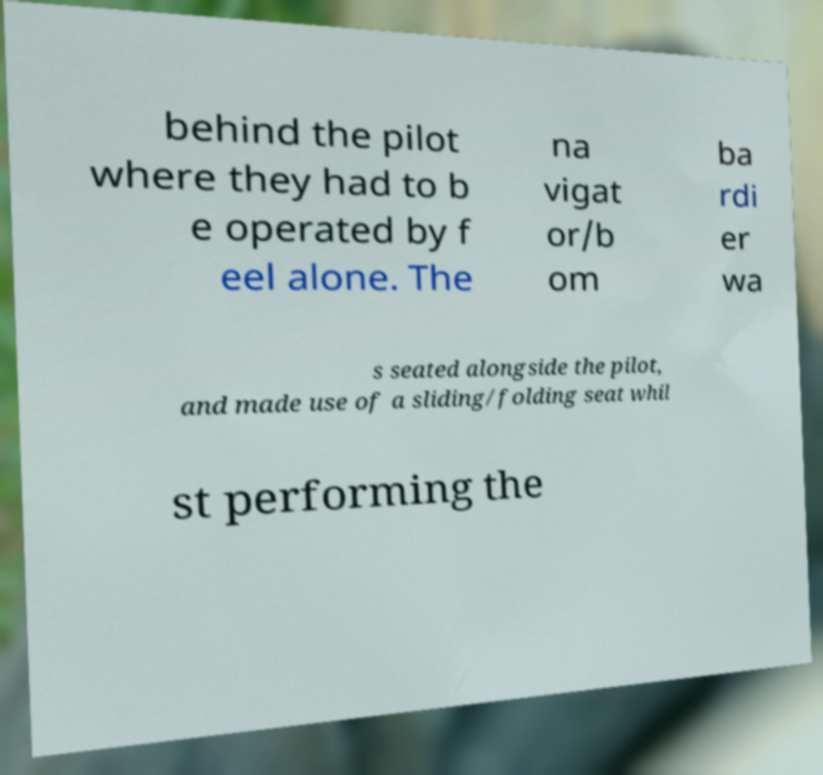I need the written content from this picture converted into text. Can you do that? behind the pilot where they had to b e operated by f eel alone. The na vigat or/b om ba rdi er wa s seated alongside the pilot, and made use of a sliding/folding seat whil st performing the 